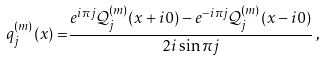<formula> <loc_0><loc_0><loc_500><loc_500>q _ { j } ^ { ( m ) } ( x ) = & \frac { e ^ { i \pi j } { \mathcal { Q } } _ { j } ^ { ( m ) } ( x + i 0 ) - e ^ { - i \pi j } { \mathcal { Q } } _ { j } ^ { ( m ) } ( x - i 0 ) } { 2 i \sin \pi j } \, ,</formula> 